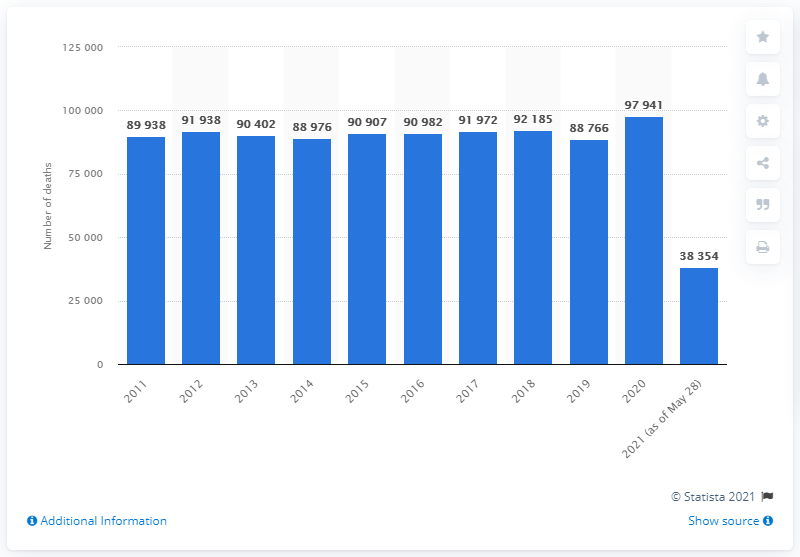List a handful of essential elements in this visual. In 2020, there were 97,941 reported deaths in Sweden. 